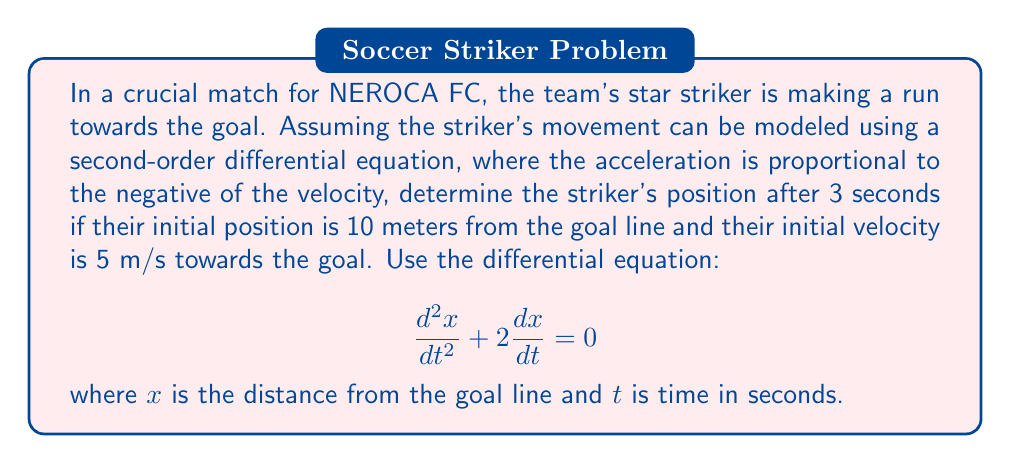What is the answer to this math problem? Let's solve this step-by-step:

1) The given differential equation is:
   $$\frac{d^2x}{dt^2} + 2\frac{dx}{dt} = 0$$

2) This is a second-order linear differential equation with constant coefficients. The general solution is:
   $$x(t) = C_1 + C_2e^{-2t}$$

3) To find $C_1$ and $C_2$, we use the initial conditions:
   At $t=0$, $x(0) = 10$ and $\frac{dx}{dt}(0) = -5$ (negative because the striker is moving towards the goal)

4) Using $x(0) = 10$:
   $$10 = C_1 + C_2$$

5) Taking the derivative of $x(t)$:
   $$\frac{dx}{dt} = -2C_2e^{-2t}$$

6) Using $\frac{dx}{dt}(0) = -5$:
   $$-5 = -2C_2$$
   $$C_2 = \frac{5}{2}$$

7) Substituting back into the equation from step 4:
   $$10 = C_1 + \frac{5}{2}$$
   $$C_1 = \frac{15}{2}$$

8) Therefore, the particular solution is:
   $$x(t) = \frac{15}{2} + \frac{5}{2}e^{-2t}$$

9) To find the position after 3 seconds, we evaluate $x(3)$:
   $$x(3) = \frac{15}{2} + \frac{5}{2}e^{-2(3)} = \frac{15}{2} + \frac{5}{2}e^{-6}$$

10) Calculating this:
    $$x(3) \approx 7.51\text{ meters}$$
Answer: 7.51 meters from the goal line 